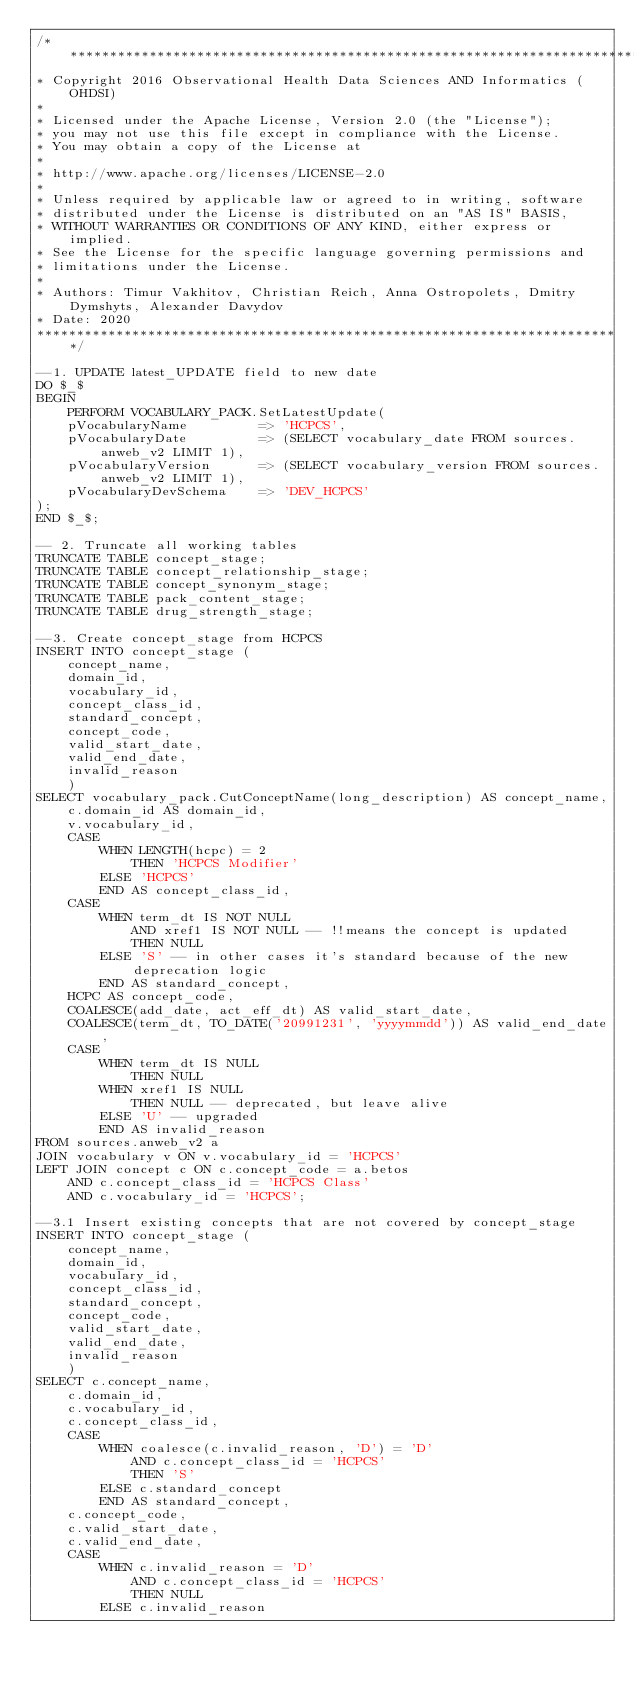<code> <loc_0><loc_0><loc_500><loc_500><_SQL_>/**************************************************************************
* Copyright 2016 Observational Health Data Sciences AND Informatics (OHDSI)
*
* Licensed under the Apache License, Version 2.0 (the "License");
* you may not use this file except in compliance with the License.
* You may obtain a copy of the License at
*
* http://www.apache.org/licenses/LICENSE-2.0
*
* Unless required by applicable law or agreed to in writing, software
* distributed under the License is distributed on an "AS IS" BASIS,
* WITHOUT WARRANTIES OR CONDITIONS OF ANY KIND, either express or implied.
* See the License for the specific language governing permissions and
* limitations under the License.
* 
* Authors: Timur Vakhitov, Christian Reich, Anna Ostropolets, Dmitry Dymshyts, Alexander Davydov
* Date: 2020
**************************************************************************/

--1. UPDATE latest_UPDATE field to new date 
DO $_$
BEGIN
	PERFORM VOCABULARY_PACK.SetLatestUpdate(
	pVocabularyName			=> 'HCPCS',
	pVocabularyDate			=> (SELECT vocabulary_date FROM sources.anweb_v2 LIMIT 1),
	pVocabularyVersion		=> (SELECT vocabulary_version FROM sources.anweb_v2 LIMIT 1),
	pVocabularyDevSchema	=> 'DEV_HCPCS'
);
END $_$;

-- 2. Truncate all working tables
TRUNCATE TABLE concept_stage;
TRUNCATE TABLE concept_relationship_stage;
TRUNCATE TABLE concept_synonym_stage;
TRUNCATE TABLE pack_content_stage;
TRUNCATE TABLE drug_strength_stage;

--3. Create concept_stage from HCPCS
INSERT INTO concept_stage (
	concept_name,
	domain_id,
	vocabulary_id,
	concept_class_id,
	standard_concept,
	concept_code,
	valid_start_date,
	valid_end_date,
	invalid_reason
	)
SELECT vocabulary_pack.CutConceptName(long_description) AS concept_name,
	c.domain_id AS domain_id,
	v.vocabulary_id,
	CASE 
		WHEN LENGTH(hcpc) = 2
			THEN 'HCPCS Modifier'
		ELSE 'HCPCS'
		END AS concept_class_id,
	CASE 
		WHEN term_dt IS NOT NULL
			AND xref1 IS NOT NULL -- !!means the concept is updated
			THEN NULL
		ELSE 'S' -- in other cases it's standard because of the new deprecation logic
		END AS standard_concept,
	HCPC AS concept_code,
	COALESCE(add_date, act_eff_dt) AS valid_start_date,
	COALESCE(term_dt, TO_DATE('20991231', 'yyyymmdd')) AS valid_end_date,
	CASE 
		WHEN term_dt IS NULL
			THEN NULL
		WHEN xref1 IS NULL
			THEN NULL -- deprecated, but leave alive
		ELSE 'U' -- upgraded
		END AS invalid_reason
FROM sources.anweb_v2 a
JOIN vocabulary v ON v.vocabulary_id = 'HCPCS'
LEFT JOIN concept c ON c.concept_code = a.betos
	AND c.concept_class_id = 'HCPCS Class'
	AND c.vocabulary_id = 'HCPCS';

--3.1 Insert existing concepts that are not covered by concept_stage
INSERT INTO concept_stage (
	concept_name,
	domain_id,
	vocabulary_id,
	concept_class_id,
	standard_concept,
	concept_code,
	valid_start_date,
	valid_end_date,
	invalid_reason
	)
SELECT c.concept_name,
	c.domain_id,
	c.vocabulary_id,
	c.concept_class_id,
	CASE 
		WHEN coalesce(c.invalid_reason, 'D') = 'D'
			AND c.concept_class_id = 'HCPCS'
			THEN 'S'
		ELSE c.standard_concept
		END AS standard_concept,
	c.concept_code,
	c.valid_start_date,
	c.valid_end_date,
	CASE 
		WHEN c.invalid_reason = 'D'
			AND c.concept_class_id = 'HCPCS'
			THEN NULL
		ELSE c.invalid_reason</code> 